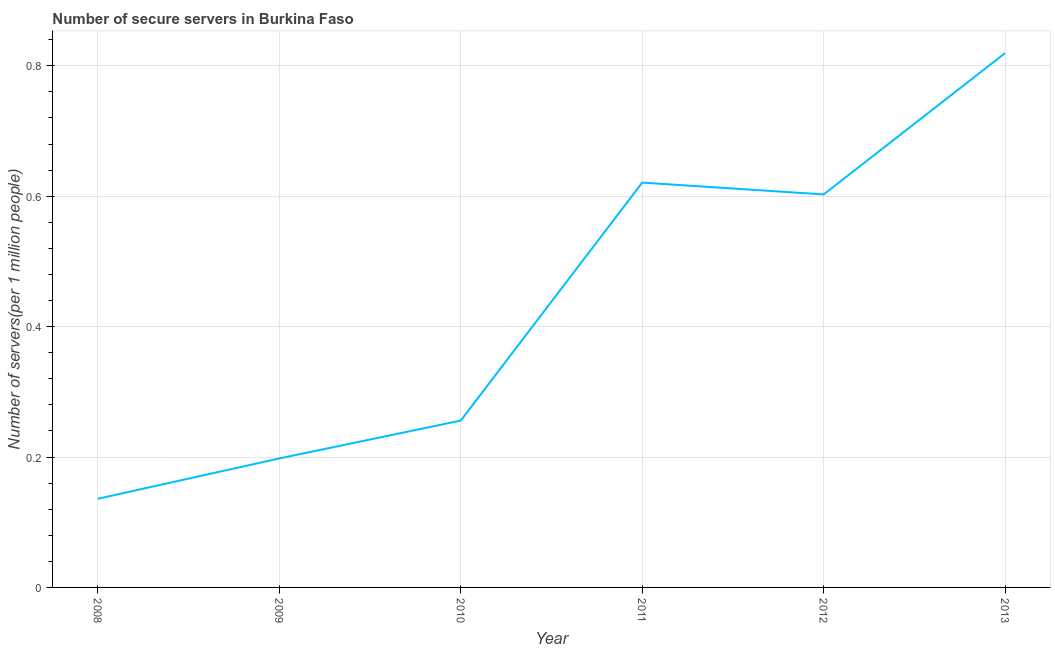What is the number of secure internet servers in 2009?
Your answer should be compact. 0.2. Across all years, what is the maximum number of secure internet servers?
Give a very brief answer. 0.82. Across all years, what is the minimum number of secure internet servers?
Give a very brief answer. 0.14. In which year was the number of secure internet servers maximum?
Offer a very short reply. 2013. What is the sum of the number of secure internet servers?
Offer a terse response. 2.63. What is the difference between the number of secure internet servers in 2008 and 2013?
Your response must be concise. -0.68. What is the average number of secure internet servers per year?
Your answer should be very brief. 0.44. What is the median number of secure internet servers?
Give a very brief answer. 0.43. In how many years, is the number of secure internet servers greater than 0.36 ?
Provide a succinct answer. 3. What is the ratio of the number of secure internet servers in 2010 to that in 2011?
Keep it short and to the point. 0.41. Is the number of secure internet servers in 2009 less than that in 2013?
Your answer should be compact. Yes. What is the difference between the highest and the second highest number of secure internet servers?
Provide a short and direct response. 0.2. What is the difference between the highest and the lowest number of secure internet servers?
Ensure brevity in your answer.  0.68. Does the graph contain any zero values?
Your answer should be compact. No. What is the title of the graph?
Make the answer very short. Number of secure servers in Burkina Faso. What is the label or title of the X-axis?
Make the answer very short. Year. What is the label or title of the Y-axis?
Ensure brevity in your answer.  Number of servers(per 1 million people). What is the Number of servers(per 1 million people) in 2008?
Offer a very short reply. 0.14. What is the Number of servers(per 1 million people) of 2009?
Offer a very short reply. 0.2. What is the Number of servers(per 1 million people) of 2010?
Provide a succinct answer. 0.26. What is the Number of servers(per 1 million people) of 2011?
Offer a very short reply. 0.62. What is the Number of servers(per 1 million people) of 2012?
Offer a terse response. 0.6. What is the Number of servers(per 1 million people) of 2013?
Keep it short and to the point. 0.82. What is the difference between the Number of servers(per 1 million people) in 2008 and 2009?
Provide a succinct answer. -0.06. What is the difference between the Number of servers(per 1 million people) in 2008 and 2010?
Make the answer very short. -0.12. What is the difference between the Number of servers(per 1 million people) in 2008 and 2011?
Your response must be concise. -0.48. What is the difference between the Number of servers(per 1 million people) in 2008 and 2012?
Make the answer very short. -0.47. What is the difference between the Number of servers(per 1 million people) in 2008 and 2013?
Ensure brevity in your answer.  -0.68. What is the difference between the Number of servers(per 1 million people) in 2009 and 2010?
Keep it short and to the point. -0.06. What is the difference between the Number of servers(per 1 million people) in 2009 and 2011?
Your answer should be compact. -0.42. What is the difference between the Number of servers(per 1 million people) in 2009 and 2012?
Your answer should be compact. -0.4. What is the difference between the Number of servers(per 1 million people) in 2009 and 2013?
Provide a succinct answer. -0.62. What is the difference between the Number of servers(per 1 million people) in 2010 and 2011?
Your response must be concise. -0.36. What is the difference between the Number of servers(per 1 million people) in 2010 and 2012?
Provide a short and direct response. -0.35. What is the difference between the Number of servers(per 1 million people) in 2010 and 2013?
Keep it short and to the point. -0.56. What is the difference between the Number of servers(per 1 million people) in 2011 and 2012?
Your answer should be very brief. 0.02. What is the difference between the Number of servers(per 1 million people) in 2011 and 2013?
Offer a terse response. -0.2. What is the difference between the Number of servers(per 1 million people) in 2012 and 2013?
Give a very brief answer. -0.22. What is the ratio of the Number of servers(per 1 million people) in 2008 to that in 2009?
Keep it short and to the point. 0.69. What is the ratio of the Number of servers(per 1 million people) in 2008 to that in 2010?
Provide a succinct answer. 0.53. What is the ratio of the Number of servers(per 1 million people) in 2008 to that in 2011?
Offer a terse response. 0.22. What is the ratio of the Number of servers(per 1 million people) in 2008 to that in 2012?
Provide a short and direct response. 0.23. What is the ratio of the Number of servers(per 1 million people) in 2008 to that in 2013?
Provide a short and direct response. 0.17. What is the ratio of the Number of servers(per 1 million people) in 2009 to that in 2010?
Your answer should be compact. 0.77. What is the ratio of the Number of servers(per 1 million people) in 2009 to that in 2011?
Your answer should be compact. 0.32. What is the ratio of the Number of servers(per 1 million people) in 2009 to that in 2012?
Your response must be concise. 0.33. What is the ratio of the Number of servers(per 1 million people) in 2009 to that in 2013?
Provide a succinct answer. 0.24. What is the ratio of the Number of servers(per 1 million people) in 2010 to that in 2011?
Provide a short and direct response. 0.41. What is the ratio of the Number of servers(per 1 million people) in 2010 to that in 2012?
Give a very brief answer. 0.42. What is the ratio of the Number of servers(per 1 million people) in 2010 to that in 2013?
Offer a very short reply. 0.31. What is the ratio of the Number of servers(per 1 million people) in 2011 to that in 2012?
Offer a very short reply. 1.03. What is the ratio of the Number of servers(per 1 million people) in 2011 to that in 2013?
Offer a very short reply. 0.76. What is the ratio of the Number of servers(per 1 million people) in 2012 to that in 2013?
Provide a succinct answer. 0.74. 